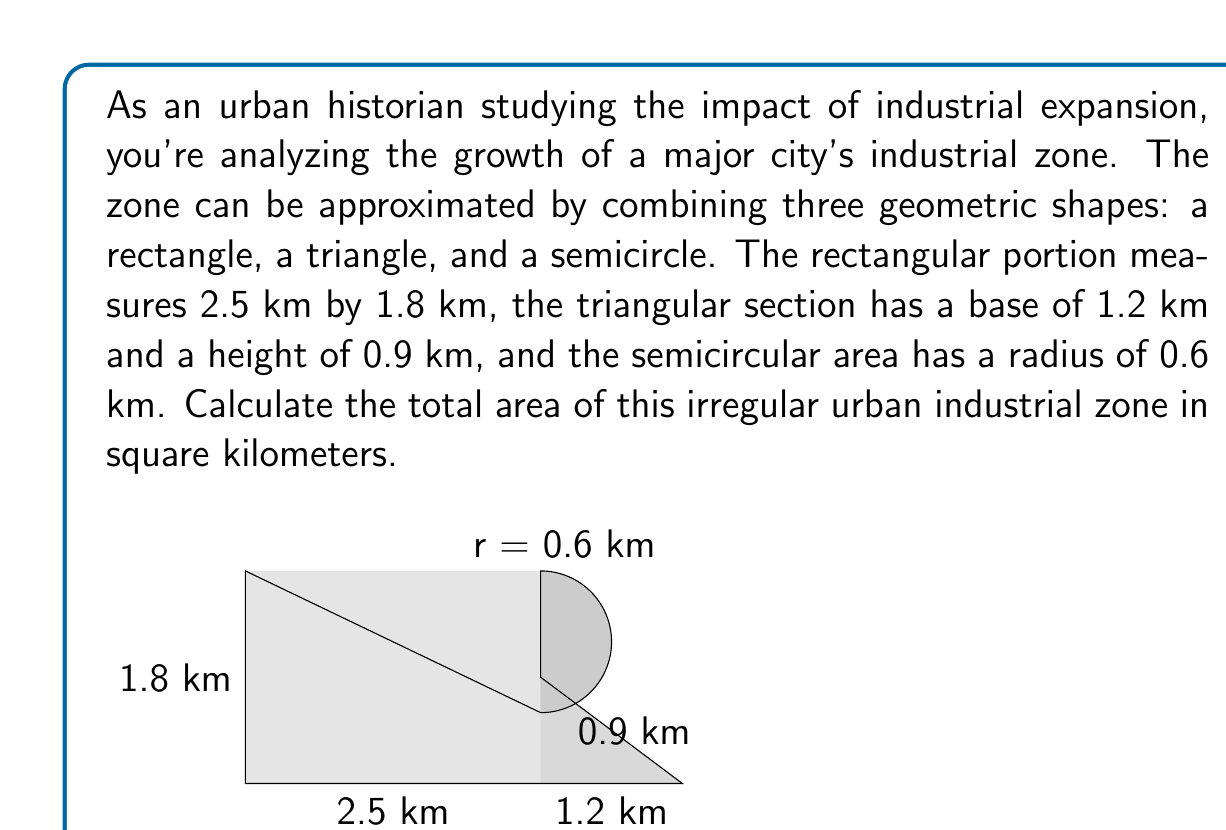Provide a solution to this math problem. To solve this problem, we need to calculate the area of each geometric shape and then sum them up:

1. Rectangle area:
   $$A_r = length \times width = 2.5 \text{ km} \times 1.8 \text{ km} = 4.5 \text{ km}^2$$

2. Triangle area:
   $$A_t = \frac{1}{2} \times base \times height = \frac{1}{2} \times 1.2 \text{ km} \times 0.9 \text{ km} = 0.54 \text{ km}^2$$

3. Semicircle area:
   First, calculate the area of a full circle and then divide by 2:
   $$A_s = \frac{1}{2} \times \pi r^2 = \frac{1}{2} \times \pi \times (0.6 \text{ km})^2 = 0.5654866776 \text{ km}^2$$

Now, sum up all the areas:
$$A_{total} = A_r + A_t + A_s$$
$$A_{total} = 4.5 \text{ km}^2 + 0.54 \text{ km}^2 + 0.5654866776 \text{ km}^2$$
$$A_{total} = 5.6054866776 \text{ km}^2$$

Rounding to two decimal places for practical purposes:
$$A_{total} \approx 5.61 \text{ km}^2$$
Answer: The total area of the irregular urban industrial zone is approximately 5.61 km². 